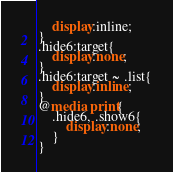Convert code to text. <code><loc_0><loc_0><loc_500><loc_500><_CSS_>	display:inline;
}
.hide6:target{
	display:none;
}
.hide6:target ~ .list{
	display:inline;
}
@media print{
	.hide6, .show6{
		display:none;
	}
}</code> 